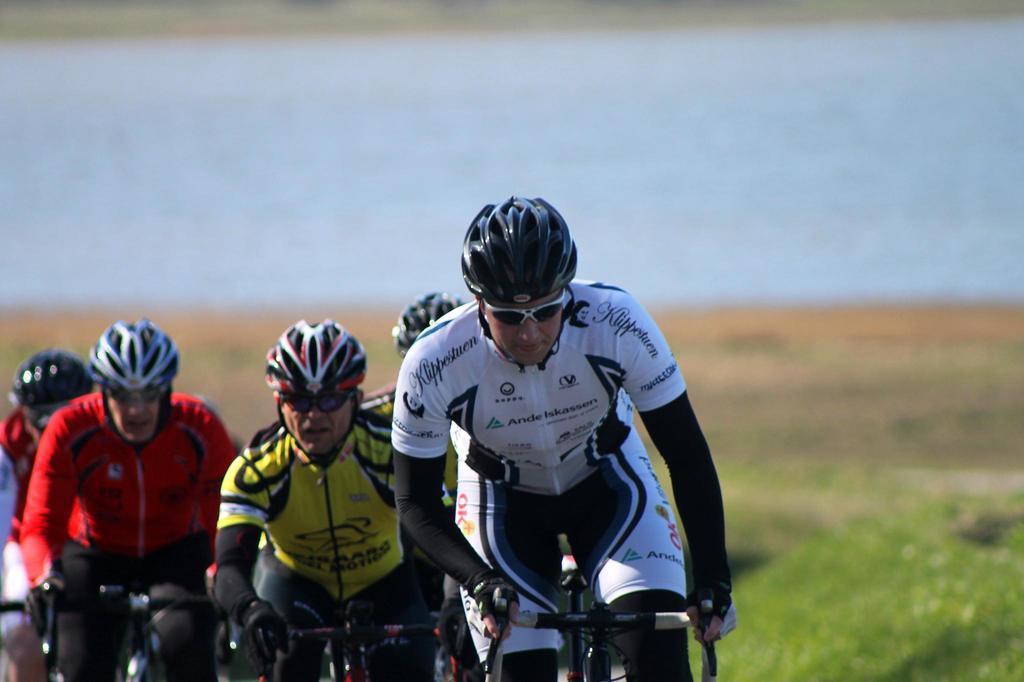What are the persons in the image doing? The persons in the image are riding bicycles. What can be seen on the ground in the right corner of the image? There is greenery on the ground in the right corner of the image. What is visible in the background of the image? There is water visible in the background of the image. What type of sweater is the person on the left wearing in the image? There is no person wearing a sweater in the image; they are riding bicycles and wearing appropriate clothing for that activity. 